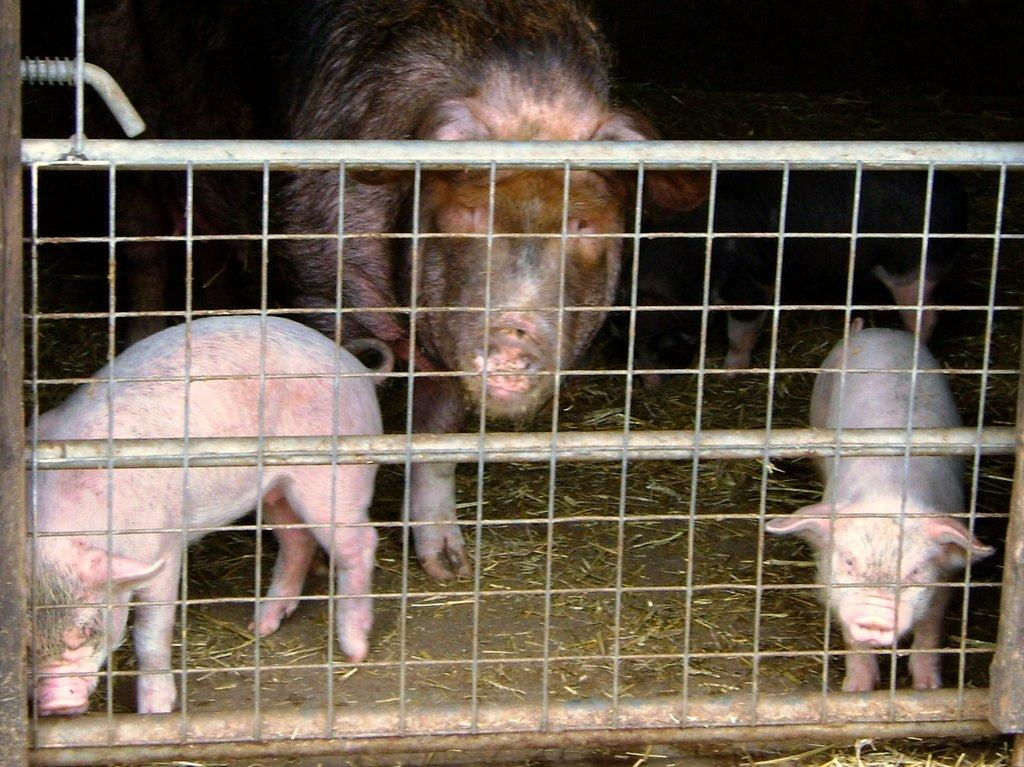What type of animals are in the image? There are pigs and piglets in the image. Where are the pigs and piglets located? The pigs and piglets are in a cage. What type of voice can be heard coming from the goldfish in the image? There are no goldfish present in the image, so it's not possible to determine what, if any, voice might be heard. 